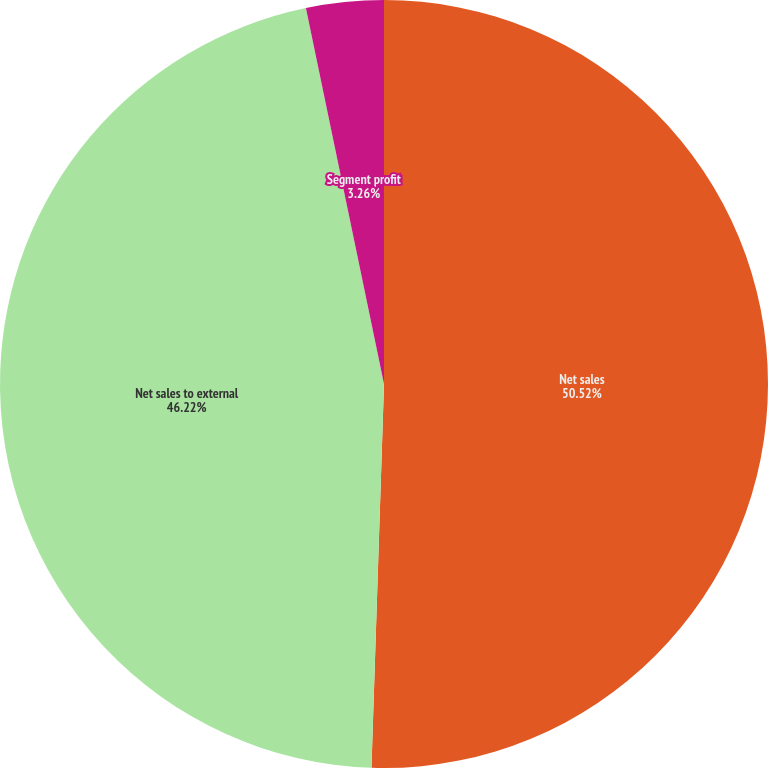Convert chart. <chart><loc_0><loc_0><loc_500><loc_500><pie_chart><fcel>Net sales<fcel>Net sales to external<fcel>Segment profit<nl><fcel>50.52%<fcel>46.22%<fcel>3.26%<nl></chart> 